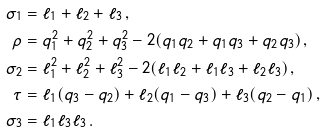<formula> <loc_0><loc_0><loc_500><loc_500>\sigma _ { 1 } & = \ell _ { 1 } + \ell _ { 2 } + \ell _ { 3 } \, , \\ \rho & = q _ { 1 } ^ { 2 } + q _ { 2 } ^ { 2 } + q _ { 3 } ^ { 2 } - 2 ( q _ { 1 } q _ { 2 } + q _ { 1 } q _ { 3 } + q _ { 2 } q _ { 3 } ) \, , \\ \sigma _ { 2 } & = \ell _ { 1 } ^ { 2 } + \ell _ { 2 } ^ { 2 } + \ell _ { 3 } ^ { 2 } - 2 ( \ell _ { 1 } \ell _ { 2 } + \ell _ { 1 } \ell _ { 3 } + \ell _ { 2 } \ell _ { 3 } ) \, , \\ \tau & = \ell _ { 1 } ( q _ { 3 } - q _ { 2 } ) + \ell _ { 2 } ( q _ { 1 } - q _ { 3 } ) + \ell _ { 3 } ( q _ { 2 } - q _ { 1 } ) \, , \\ \sigma _ { 3 } & = \ell _ { 1 } \ell _ { 3 } \ell _ { 3 } \, .</formula> 